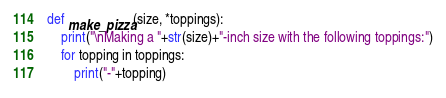<code> <loc_0><loc_0><loc_500><loc_500><_Python_>def make_pizza(size, *toppings):
    print("\nMaking a "+str(size)+"-inch size with the following toppings:")
    for topping in toppings:
        print("-"+topping)
</code> 